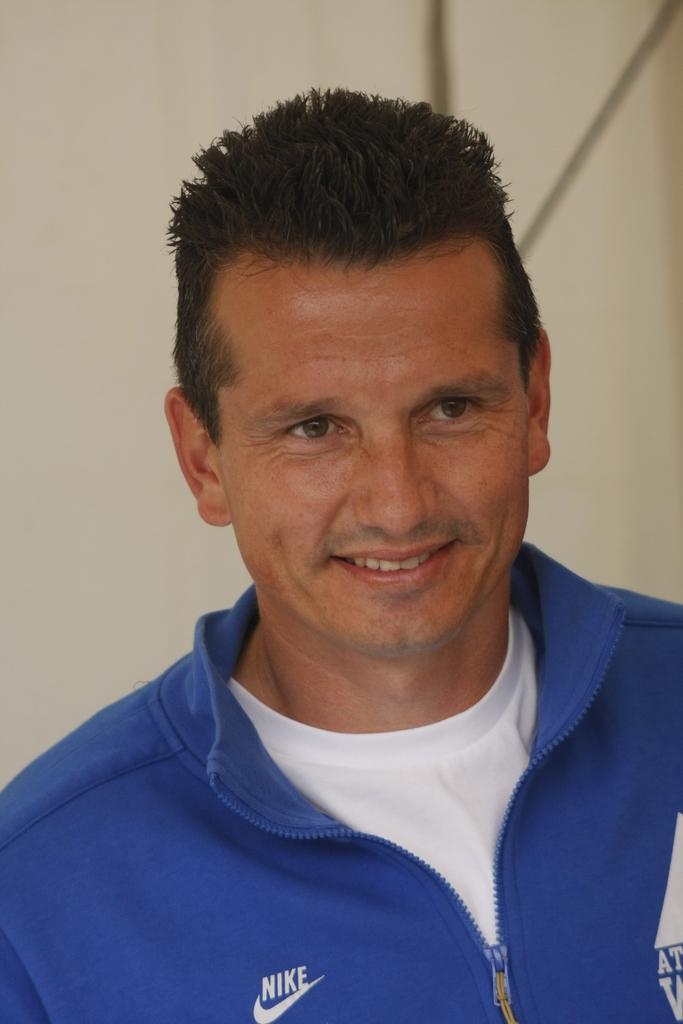Who is present in the image? There is a man in the image. What is the man wearing in the image? The man is wearing a blue jacket. What can be seen in the background of the image? There is a wall in the background of the image. What types of toys can be seen in the image? There are no toys present in the image. Are there any fairies visible in the image? There are no fairies present in the image. 